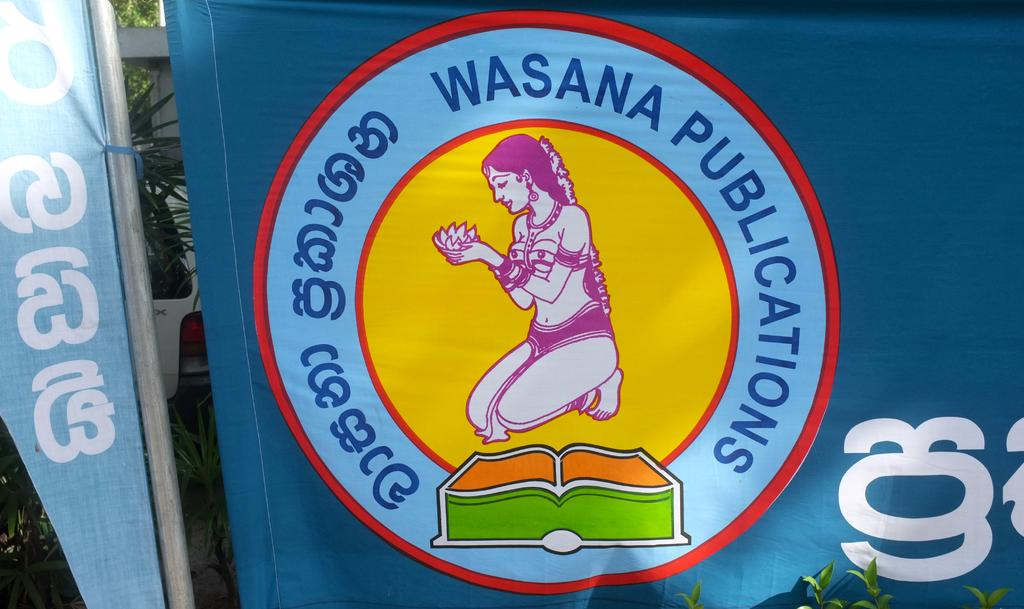What is featured in the image along with text? There is a logo in the image. Can you describe the text in the image? The text in the image is not specified, but it is present alongside the logo. What can be seen in the background of the image? Plants are visible in the background of the image. Where are leaves located in the image? Leaves are visible at the right bottom of the image. What type of yarn is being used to create the coat in the image? There is no coat or yarn present in the image; it features a logo, text, plants, and leaves. 